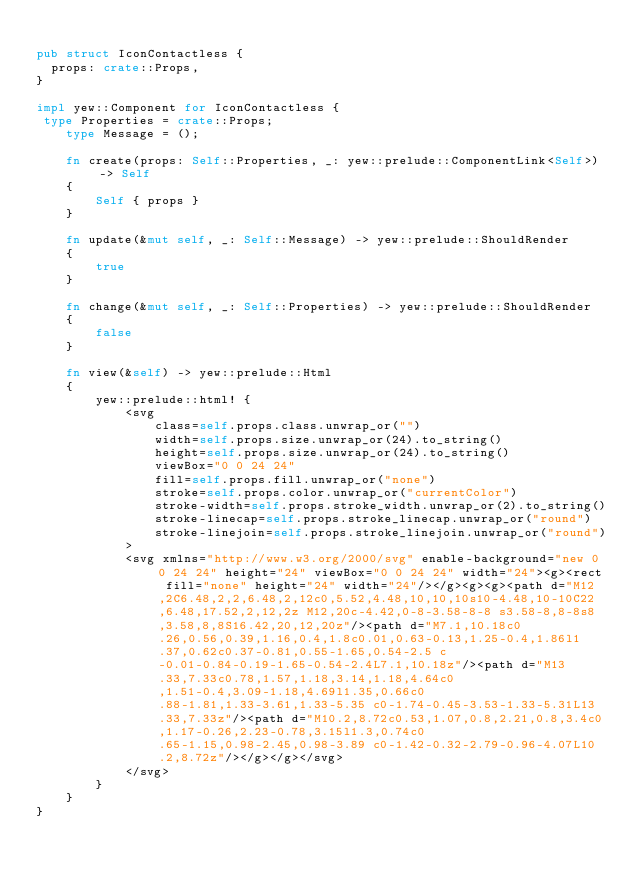<code> <loc_0><loc_0><loc_500><loc_500><_Rust_>
pub struct IconContactless {
  props: crate::Props,
}

impl yew::Component for IconContactless {
 type Properties = crate::Props;
    type Message = ();

    fn create(props: Self::Properties, _: yew::prelude::ComponentLink<Self>) -> Self
    {
        Self { props }
    }

    fn update(&mut self, _: Self::Message) -> yew::prelude::ShouldRender
    {
        true
    }

    fn change(&mut self, _: Self::Properties) -> yew::prelude::ShouldRender
    {
        false
    }

    fn view(&self) -> yew::prelude::Html
    {
        yew::prelude::html! {
            <svg
                class=self.props.class.unwrap_or("")
                width=self.props.size.unwrap_or(24).to_string()
                height=self.props.size.unwrap_or(24).to_string()
                viewBox="0 0 24 24"
                fill=self.props.fill.unwrap_or("none")
                stroke=self.props.color.unwrap_or("currentColor")
                stroke-width=self.props.stroke_width.unwrap_or(2).to_string()
                stroke-linecap=self.props.stroke_linecap.unwrap_or("round")
                stroke-linejoin=self.props.stroke_linejoin.unwrap_or("round")
            >
            <svg xmlns="http://www.w3.org/2000/svg" enable-background="new 0 0 24 24" height="24" viewBox="0 0 24 24" width="24"><g><rect fill="none" height="24" width="24"/></g><g><g><path d="M12,2C6.48,2,2,6.48,2,12c0,5.52,4.48,10,10,10s10-4.48,10-10C22,6.48,17.52,2,12,2z M12,20c-4.42,0-8-3.58-8-8 s3.58-8,8-8s8,3.58,8,8S16.42,20,12,20z"/><path d="M7.1,10.18c0.26,0.56,0.39,1.16,0.4,1.8c0.01,0.63-0.13,1.25-0.4,1.86l1.37,0.62c0.37-0.81,0.55-1.65,0.54-2.5 c-0.01-0.84-0.19-1.65-0.54-2.4L7.1,10.18z"/><path d="M13.33,7.33c0.78,1.57,1.18,3.14,1.18,4.64c0,1.51-0.4,3.09-1.18,4.69l1.35,0.66c0.88-1.81,1.33-3.61,1.33-5.35 c0-1.74-0.45-3.53-1.33-5.31L13.33,7.33z"/><path d="M10.2,8.72c0.53,1.07,0.8,2.21,0.8,3.4c0,1.17-0.26,2.23-0.78,3.15l1.3,0.74c0.65-1.15,0.98-2.45,0.98-3.89 c0-1.42-0.32-2.79-0.96-4.07L10.2,8.72z"/></g></g></svg>
            </svg>
        }
    }
}


</code> 